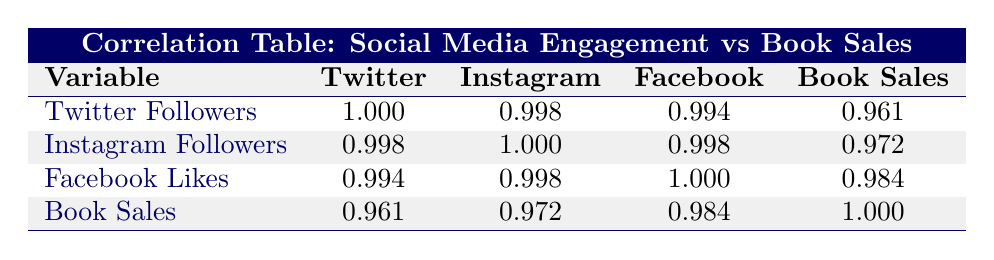What is the correlation coefficient between Twitter followers and book sales? From the table, the correlation coefficient for Twitter followers and book sales is found in the corresponding row and column, which shows a value of 0.961.
Answer: 0.961 What is the highest correlation value in the table? By examining the correlation values in the table, the highest correlation value appears between Facebook likes and book sales, which is 0.984.
Answer: 0.984 Is there a strong correlation between Instagram followers and Facebook likes? Looking at the table, the correlation coefficient between Instagram followers and Facebook likes is 0.998, which indicates a very strong correlation.
Answer: Yes What is the difference between the correlation values of Twitter followers and Instagram followers with book sales? The correlation for Twitter followers with book sales is 0.961, and for Instagram followers, it is 0.972. The difference is calculated as 0.972 - 0.961 = 0.011.
Answer: 0.011 If author V.E. Schwab's followers on all three platforms increased by 10%, how would that affect the correlation values? The correlation values likely wouldn't change significantly with a uniform increase across social media platforms, as the relative rankings of follower counts would be maintained.
Answer: Not significantly What are the average correlation values for social media platforms with respect to book sales? The averages are calculated as follows: Twitter (0.961) + Instagram (0.972) + Facebook (0.984) = 2.917, and then divided by three gives an average of 0.9723.
Answer: 0.9723 Is Tomi Adeyemi's book sales higher than the average book sales from authors in the table? The total book sales from all authors are 5000 + 10000 + 15000 + 2000 + 7500 + 500 + 30000 = 57700, and the average is 57700/7 = 8257.14, Tomi Adeyemi's sales are 15000 which is higher.
Answer: Yes What is the correlation coefficient of Facebook likes with Instagram followers? The table shows that the correlation coefficient between Facebook likes and Instagram followers is 0.998.
Answer: 0.998 What is the correlation value for social media engagements with the highest book sales? Looking at the data points, V.E. Schwab has total book sales of 30000, with correlation values of Twitter (0.961), Instagram (0.972), and Facebook (0.984). The highest is Facebook at 0.984.
Answer: 0.984 